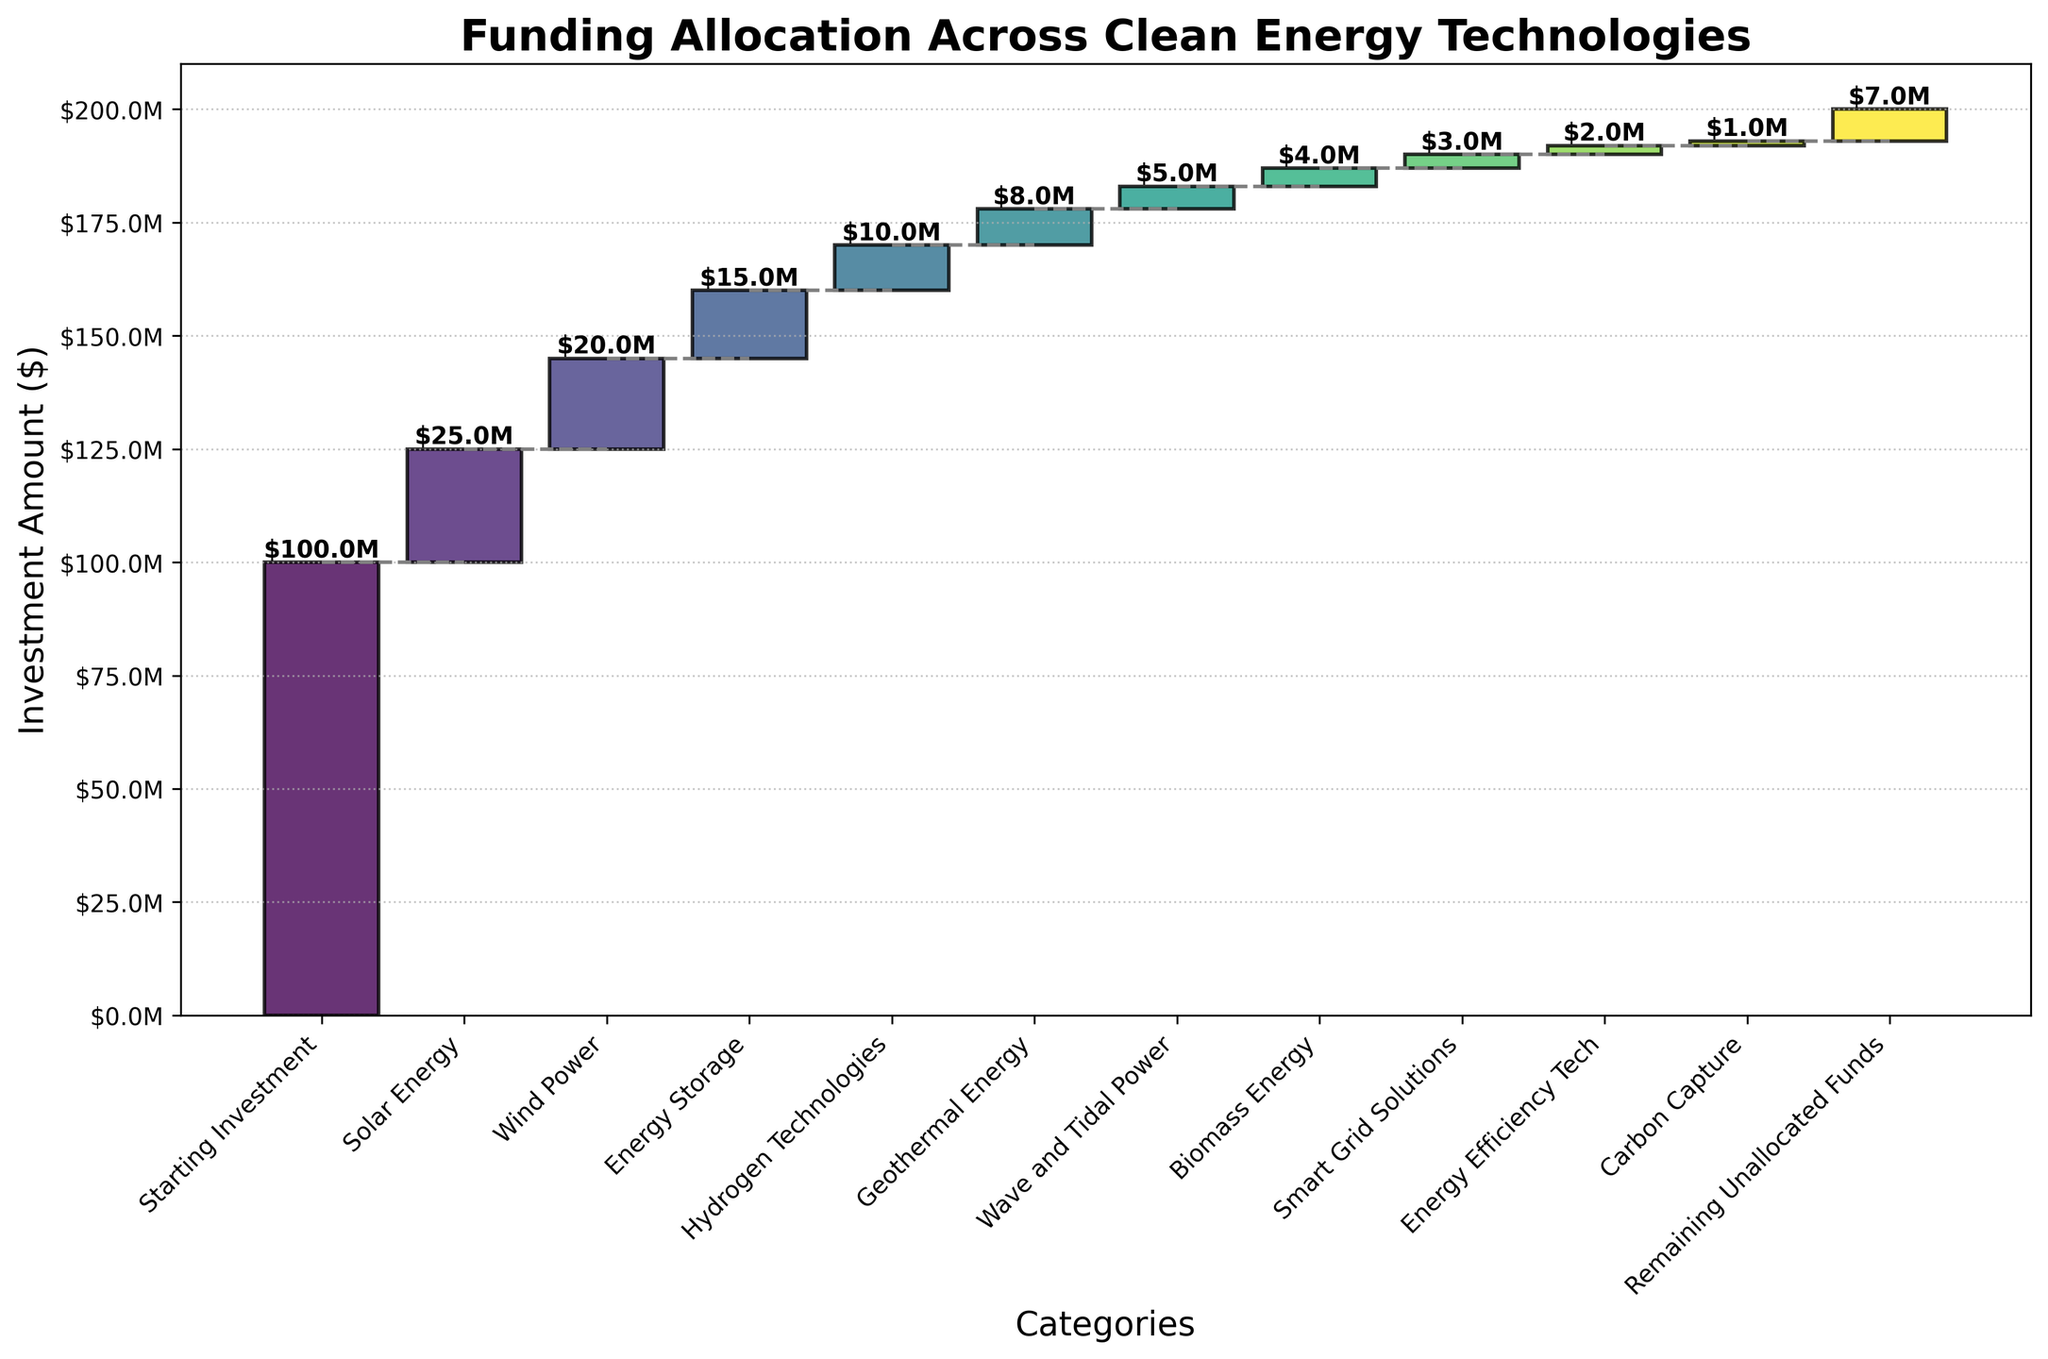What is the title of the waterfall chart? The title is usually located at the top of the chart. It provides a summary of the data being presented. By looking at the top, one can read it directly.
Answer: Funding Allocation Across Clean Energy Technologies What is the total amount of the initial investment? To find the total amount of the initial investment, look at the first bar in the chart, which usually represents the starting point or baseline for the waterfall chart.
Answer: $100,000,000 Which clean energy technology has the highest allocated funding? Identify the bar with the greatest value excluding the starting and ending points. This would be the highest bar among the intermediate categories.
Answer: Solar Energy What is the cumulative amount of investments after Hydrogen Technologies? To determine this, add the values of the initial investment, Solar Energy, Wind Power, Energy Storage, and Hydrogen Technologies.
Answer: $70,000,000 How much funding is left unallocated? Look at the last bar in the chart, which typically represents the remaining or final value. This can be directly read off the chart.
Answer: $7,000,000 What is the total investment in Energy Efficiency Tech and Carbon Capture? Sum the values of Energy Efficiency Tech and Carbon Capture, which can be found by locating these two categories in the chart.
Answer: $3,000,000 How does the funding for Wind Power compare to that for Geothermal Energy? Compare the values of the bars associated with Wind Power and Geothermal Energy. Check whether Wind Power is greater than, equal to, or less than Geothermal Energy.
Answer: Wind Power is greater Which technology has the lowest funding allocation, and what is the amount? Identify the smallest value among the bars that represent specific clean energy technologies.
Answer: Carbon Capture; $1,000,000 What is the average amount of funding across all the clean energy technologies funded? Sum the values for all the clean energy categories (excluding the starting investment and remaining funds) and divide by the number of these categories.
Answer: $10,181,818.18 